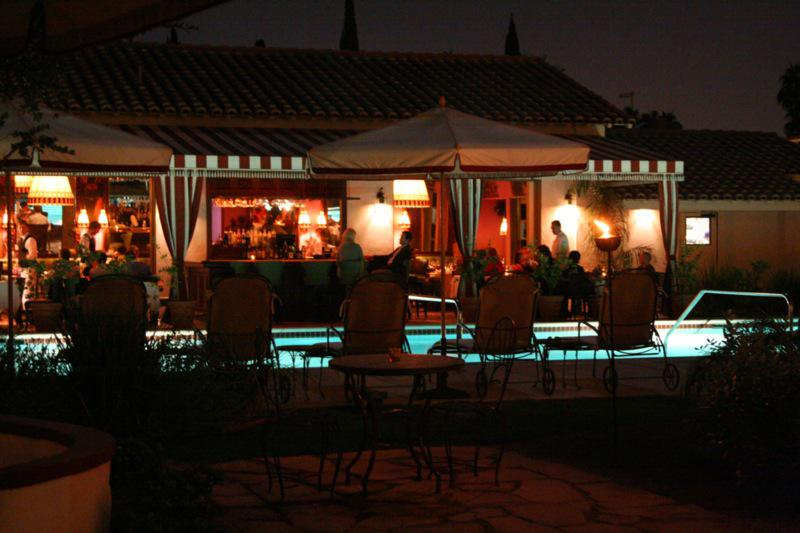Question: where is this picture taken?
Choices:
A. By the pool.
B. Poolside bar.
C. In a cafe.
D. By a water slide.
Answer with the letter. Answer: B Question: what pattern is the awning?
Choices:
A. Lattice work pattern.
B. Striped.
C. Polka dotted.
D. Color blocked.
Answer with the letter. Answer: B Question: what kind of roof is on the building?
Choices:
A. Shingles.
B. Tile.
C. Brick.
D. Glass.
Answer with the letter. Answer: B Question: what time of day is it?
Choices:
A. Evening.
B. Dusk.
C. Twilight.
D. Night.
Answer with the letter. Answer: D Question: where are people sitting?
Choices:
A. Grass.
B. Tables.
C. Benches.
D. Chairs.
Answer with the letter. Answer: B Question: what is striped?
Choices:
A. Awning.
B. The road.
C. A building.
D. A zebra.
Answer with the letter. Answer: A Question: how many empty chairs?
Choices:
A. Three.
B. Five.
C. One.
D. Seven.
Answer with the letter. Answer: B Question: what has no people swimming in it?
Choices:
A. Polluted lake.
B. Pool.
C. The ocean.
D. A fast moving river.
Answer with the letter. Answer: B Question: what is covered by a canopy?
Choices:
A. Chili Cook off contestants.
B. An Auctioneer.
C. A funeral grave site.
D. Bar.
Answer with the letter. Answer: D Question: what is behind the pool?
Choices:
A. Trees.
B. Cactus.
C. Vegetation.
D. A fence.
Answer with the letter. Answer: C Question: what is patterned in brown, blue or white?
Choices:
A. Canopy.
B. Awning.
C. Tent.
D. A tarp.
Answer with the letter. Answer: B Question: what are empty?
Choices:
A. Chairs.
B. Stadium seats.
C. Bar stools.
D. The auditorium.
Answer with the letter. Answer: A Question: what is illuminated?
Choices:
A. The plastic fake ice cubes in my drink.
B. The twinkle lights in the hedges.
C. The string lights under the umbrella.
D. Pool.
Answer with the letter. Answer: D Question: how many lounge chairs are by the pool?
Choices:
A. Five.
B. Six.
C. Ten.
D. Twelve.
Answer with the letter. Answer: A 